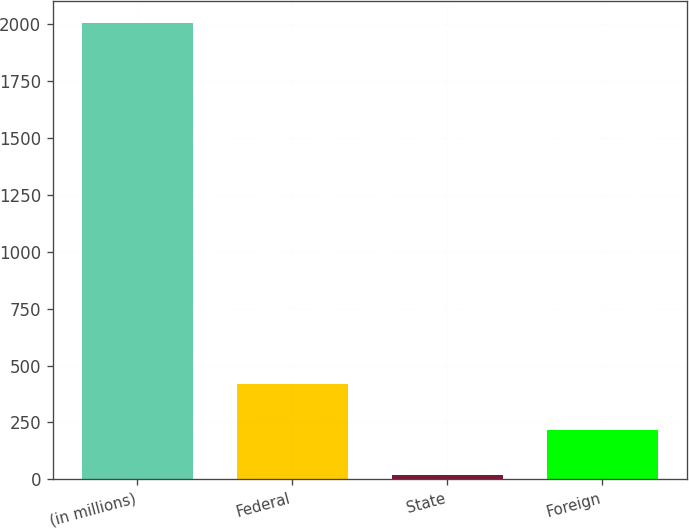Convert chart. <chart><loc_0><loc_0><loc_500><loc_500><bar_chart><fcel>(in millions)<fcel>Federal<fcel>State<fcel>Foreign<nl><fcel>2004<fcel>416.8<fcel>20<fcel>218.4<nl></chart> 